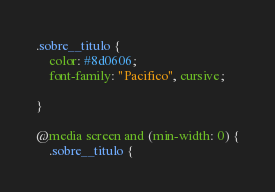<code> <loc_0><loc_0><loc_500><loc_500><_CSS_>.sobre__titulo {
    color: #8d0606;
    font-family: "Pacifico", cursive;
    
}

@media screen and (min-width: 0) {
    .sobre__titulo {</code> 